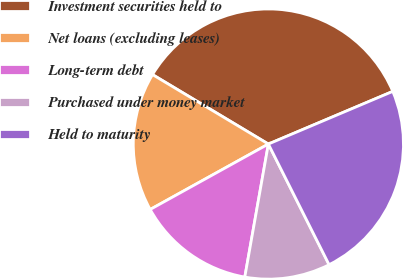<chart> <loc_0><loc_0><loc_500><loc_500><pie_chart><fcel>Investment securities held to<fcel>Net loans (excluding leases)<fcel>Long-term debt<fcel>Purchased under money market<fcel>Held to maturity<nl><fcel>35.03%<fcel>16.64%<fcel>14.16%<fcel>10.21%<fcel>23.95%<nl></chart> 